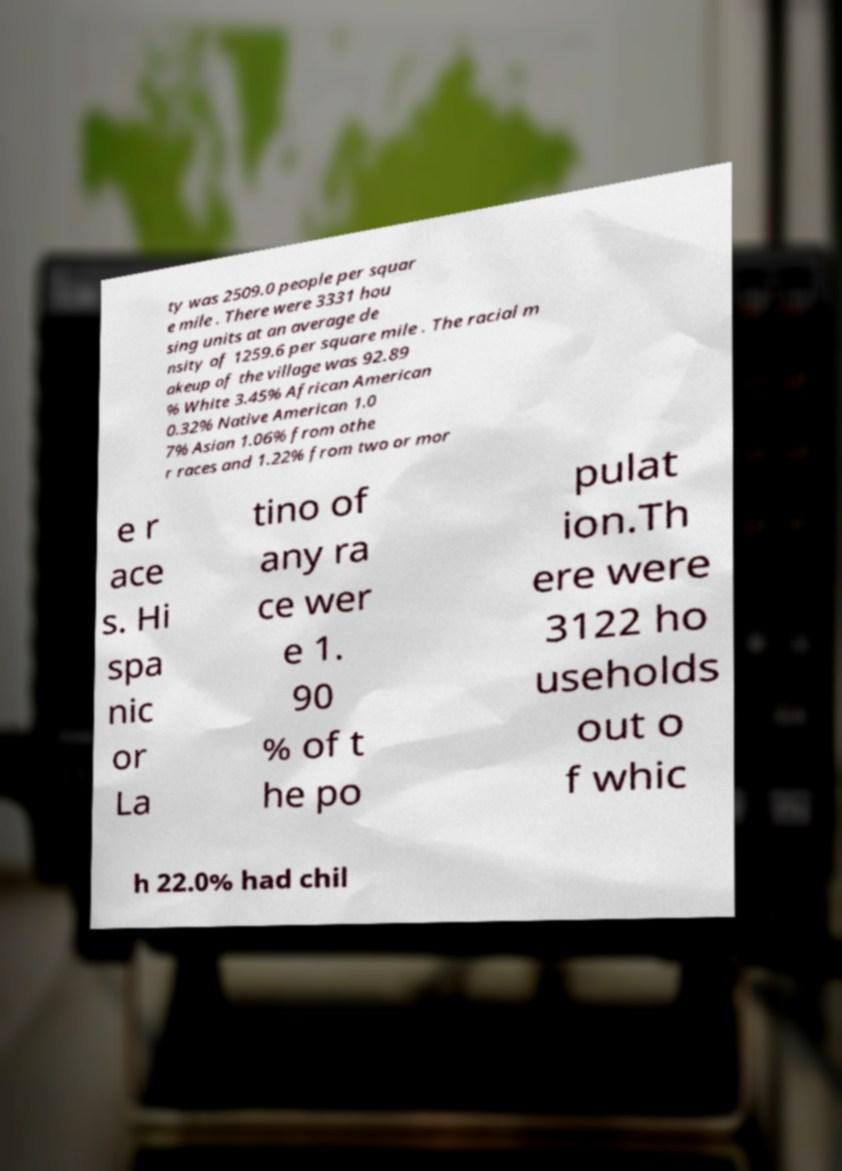I need the written content from this picture converted into text. Can you do that? ty was 2509.0 people per squar e mile . There were 3331 hou sing units at an average de nsity of 1259.6 per square mile . The racial m akeup of the village was 92.89 % White 3.45% African American 0.32% Native American 1.0 7% Asian 1.06% from othe r races and 1.22% from two or mor e r ace s. Hi spa nic or La tino of any ra ce wer e 1. 90 % of t he po pulat ion.Th ere were 3122 ho useholds out o f whic h 22.0% had chil 